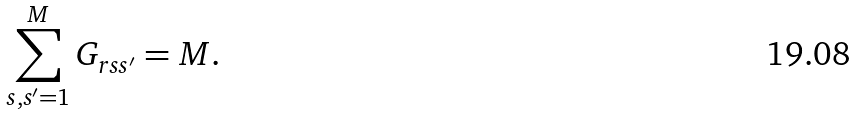Convert formula to latex. <formula><loc_0><loc_0><loc_500><loc_500>\sum _ { s , s ^ { \prime } = 1 } ^ { M } G _ { r s s ^ { \prime } } = M .</formula> 